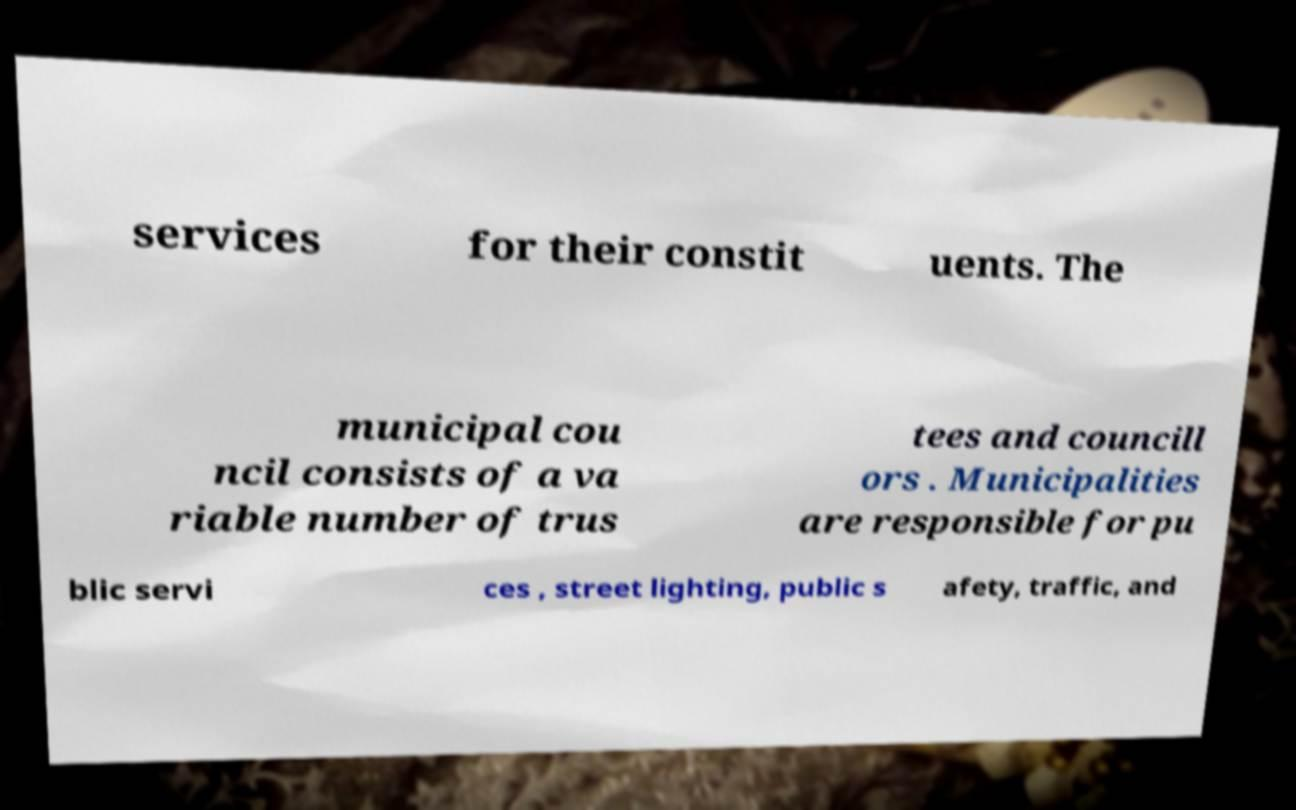Can you read and provide the text displayed in the image?This photo seems to have some interesting text. Can you extract and type it out for me? services for their constit uents. The municipal cou ncil consists of a va riable number of trus tees and councill ors . Municipalities are responsible for pu blic servi ces , street lighting, public s afety, traffic, and 